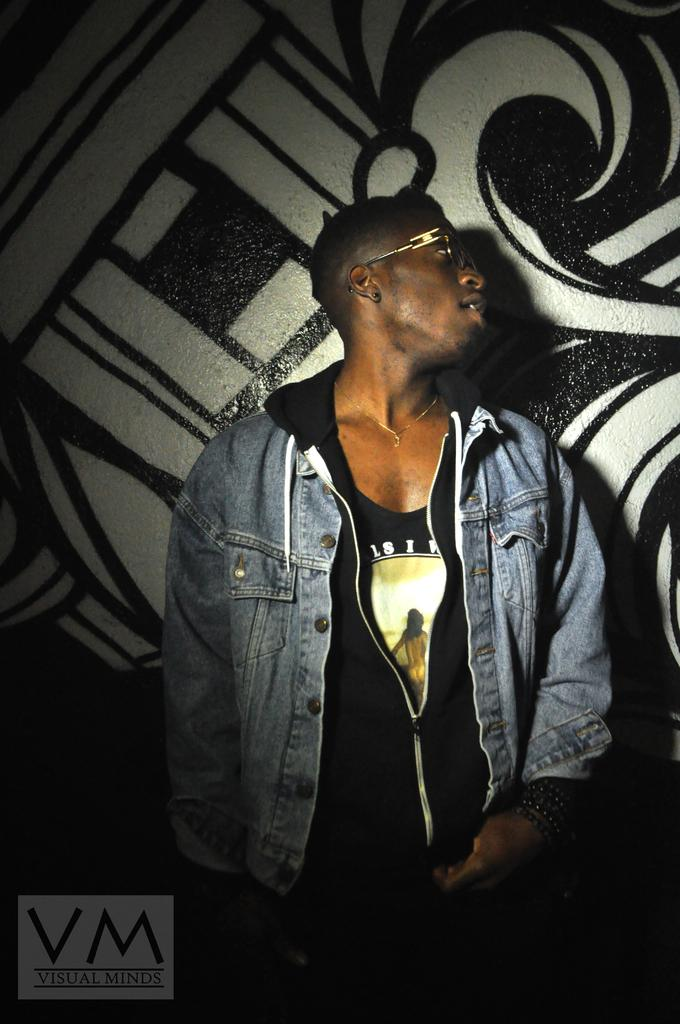Who or what is the main subject in the image? There is a person in the image. What can be observed about the person's appearance? The person is wearing spectacles. Can you describe the background of the image? There may be a wall behind the person, and if so, there is a design on the wall. Is there any text present in the image? There may be text at the bottom of the image. How many stars are visible in the image? There are no stars visible in the image. What type of competition is the person participating in within the image? There is no competition present in the image; it only features a person wearing spectacles. 